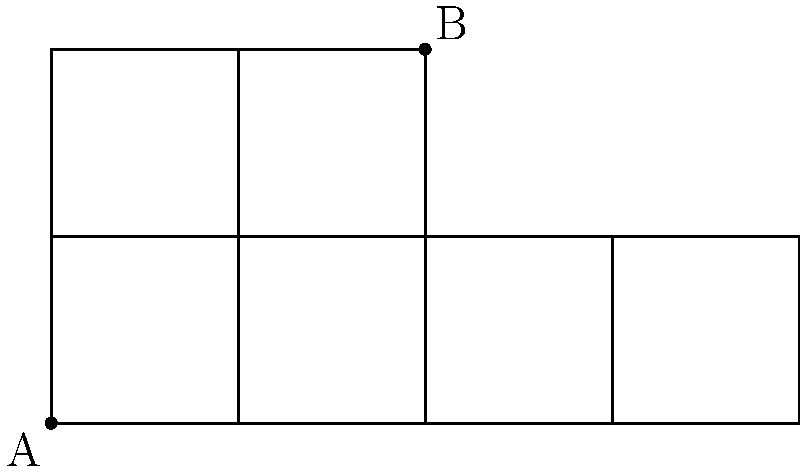Consider a unit cube with point A at (0,0,0) and point B at (1,1,1). When the cube is unfolded into a planar net as shown in the figure, what is the shortest path length between points A and B on the surface of the cube? Express your answer in terms of the cube's edge length. To solve this problem, we need to follow these steps:

1) Recognize that the shortest path on the cube's surface corresponds to a straight line on the unfolded net.

2) Identify the possible paths on the unfolded net:
   - Path 1: Directly from A to B
   - Path 2: From A to B, crossing the edge between the front and right faces

3) Calculate the length of Path 1:
   The direct distance between A and B on the unfolded net is the diagonal of a 2x2 square.
   Length of Path 1 = $\sqrt{2^2 + 2^2} = \sqrt{8} = 2\sqrt{2}$

4) Calculate the length of Path 2:
   This path consists of two segments: from A to the edge, and from the edge to B.
   - Distance from A to edge: $\sqrt{1^2 + 1^2} = \sqrt{2}$
   - Distance from edge to B: $\sqrt{1^2 + 1^2} = \sqrt{2}$
   Length of Path 2 = $\sqrt{2} + \sqrt{2} = 2\sqrt{2}$

5) Compare the two path lengths:
   Both paths have the same length of $2\sqrt{2}$.

6) Express the answer in terms of the cube's edge length:
   If we denote the cube's edge length as $a$, the shortest path length would be $2\sqrt{2}a$.

Therefore, the shortest path length between A and B on the surface of the cube is $2\sqrt{2}$ times the edge length of the cube.
Answer: $2\sqrt{2}$ times the cube's edge length 